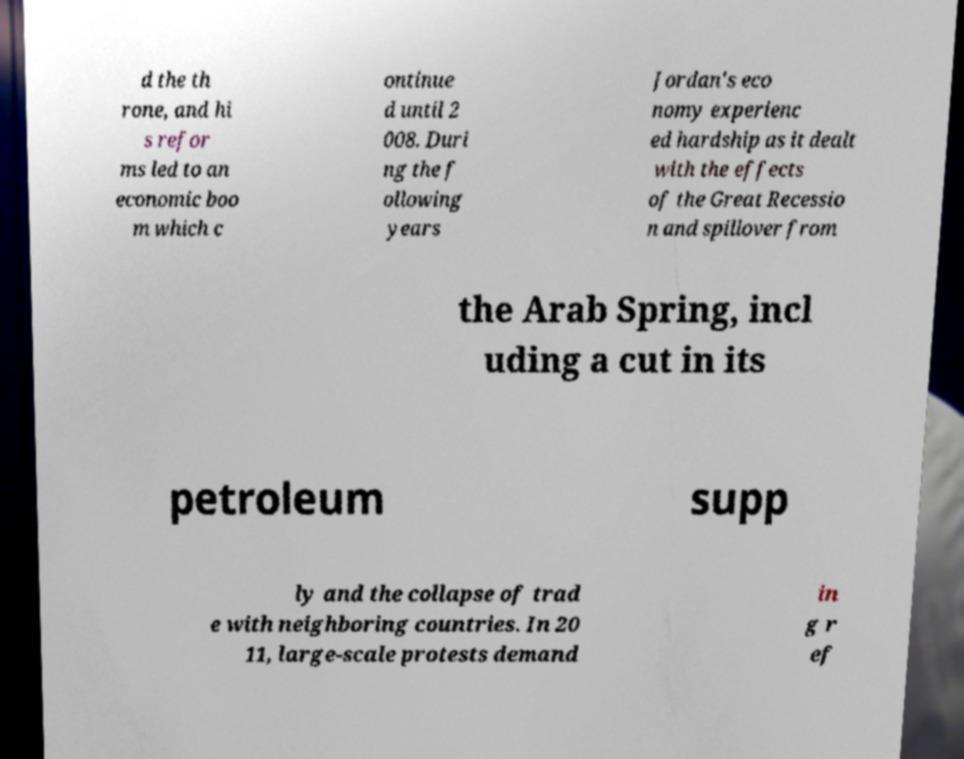Can you read and provide the text displayed in the image?This photo seems to have some interesting text. Can you extract and type it out for me? d the th rone, and hi s refor ms led to an economic boo m which c ontinue d until 2 008. Duri ng the f ollowing years Jordan's eco nomy experienc ed hardship as it dealt with the effects of the Great Recessio n and spillover from the Arab Spring, incl uding a cut in its petroleum supp ly and the collapse of trad e with neighboring countries. In 20 11, large-scale protests demand in g r ef 